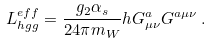<formula> <loc_0><loc_0><loc_500><loc_500>L ^ { e f f } _ { h g g } = \frac { g _ { 2 } \alpha _ { s } } { 2 4 \pi m _ { W } } h G ^ { a } _ { \mu \nu } G ^ { a \mu \nu } \, .</formula> 